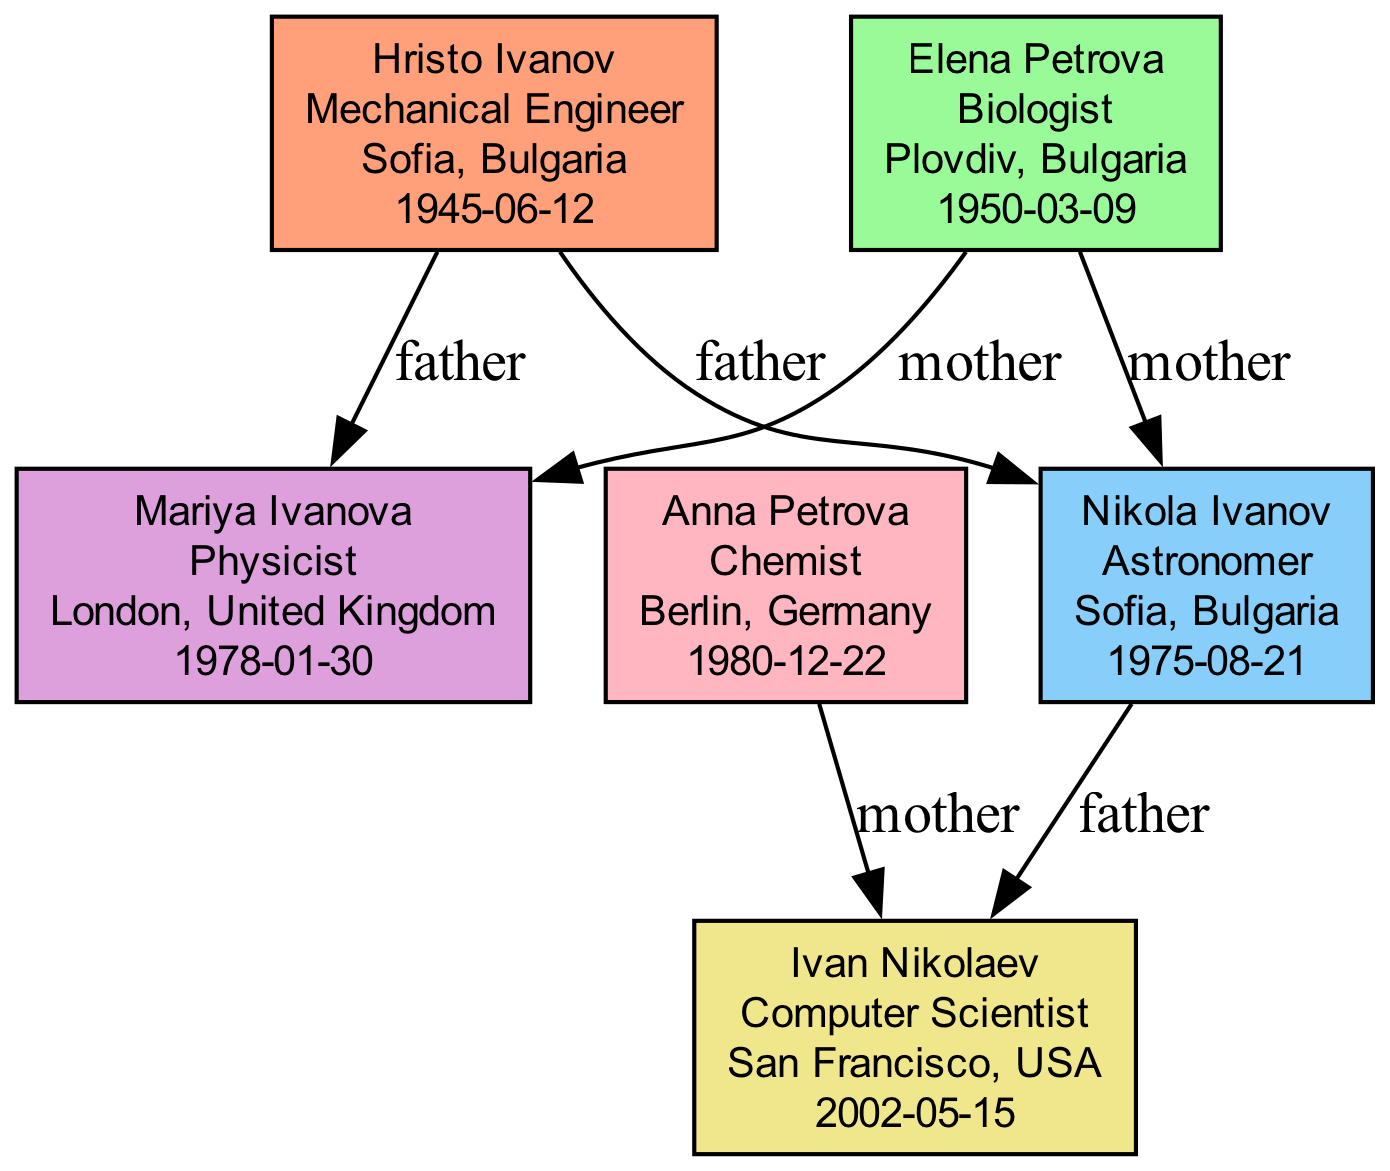What is the profession of Hristo Ivanov? The diagram shows that Hristo Ivanov is labeled with the profession "Mechanical Engineer."
Answer: Mechanical Engineer Which family member is associated with San Francisco? The diagram indicates that Ivan Nikolaev, who has the profession "Computer Scientist," is located in San Francisco, USA.
Answer: Ivan Nikolaev How many nodes are there in total? By counting each individual node displayed in the diagram, there are six family members represented.
Answer: 6 What is the relationship between Nikola Ivanov and Hristo Ivanov? The diagram presents an edge labeled "father" connecting Nikola Ivanov to Hristo Ivanov, indicating that Hristo Ivanov is Nikola Ivanov's father.
Answer: father Which profession is represented in London? According to the diagram, Mariya Ivanova, a "Physicist," is located in London, United Kingdom.
Answer: Physicist Who is the mother of Ivan Nikolaev? The diagram shows an edge connecting Anna Petrova to Ivan Nikolaev, with the label "mother," indicating that Anna Petrova is Ivan Nikolaev's mother.
Answer: Anna Petrova What is the common profession of Hristo Ivanov and Elena Petrova? Both family members, Hristo Ivanov as a "Mechanical Engineer" and Elena Petrova as a "Biologist," have different professions, making the answer one of non-identity.
Answer: None Which two locations are represented by the family members? The diagram shows family members in Sofia, Bulgaria, and San Francisco, USA, as well as London, United Kingdom, and Berlin, Germany. Each of these locations belongs to one or more family members.
Answer: Sofia, San Francisco, London, Berlin What is the geographical trend in the professional evolution of the family members? Analyzing the diagram, it reveals a geographical migration from Sofia, Bulgaria, to various locations such as London, Berlin, and San Francisco, showing the spread across Europe to the USA.
Answer: Spread across multiple locations globally 